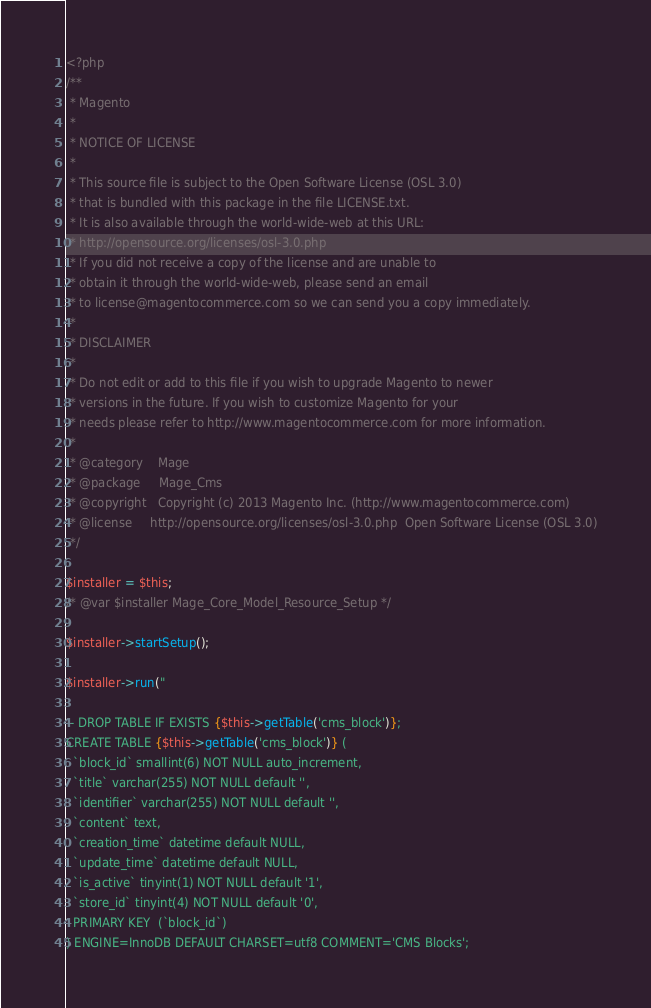Convert code to text. <code><loc_0><loc_0><loc_500><loc_500><_PHP_><?php
/**
 * Magento
 *
 * NOTICE OF LICENSE
 *
 * This source file is subject to the Open Software License (OSL 3.0)
 * that is bundled with this package in the file LICENSE.txt.
 * It is also available through the world-wide-web at this URL:
 * http://opensource.org/licenses/osl-3.0.php
 * If you did not receive a copy of the license and are unable to
 * obtain it through the world-wide-web, please send an email
 * to license@magentocommerce.com so we can send you a copy immediately.
 *
 * DISCLAIMER
 *
 * Do not edit or add to this file if you wish to upgrade Magento to newer
 * versions in the future. If you wish to customize Magento for your
 * needs please refer to http://www.magentocommerce.com for more information.
 *
 * @category    Mage
 * @package     Mage_Cms
 * @copyright   Copyright (c) 2013 Magento Inc. (http://www.magentocommerce.com)
 * @license     http://opensource.org/licenses/osl-3.0.php  Open Software License (OSL 3.0)
 */

$installer = $this;
/* @var $installer Mage_Core_Model_Resource_Setup */

$installer->startSetup();

$installer->run("

-- DROP TABLE IF EXISTS {$this->getTable('cms_block')};
CREATE TABLE {$this->getTable('cms_block')} (
  `block_id` smallint(6) NOT NULL auto_increment,
  `title` varchar(255) NOT NULL default '',
  `identifier` varchar(255) NOT NULL default '',
  `content` text,
  `creation_time` datetime default NULL,
  `update_time` datetime default NULL,
  `is_active` tinyint(1) NOT NULL default '1',
  `store_id` tinyint(4) NOT NULL default '0',
  PRIMARY KEY  (`block_id`)
) ENGINE=InnoDB DEFAULT CHARSET=utf8 COMMENT='CMS Blocks';
</code> 